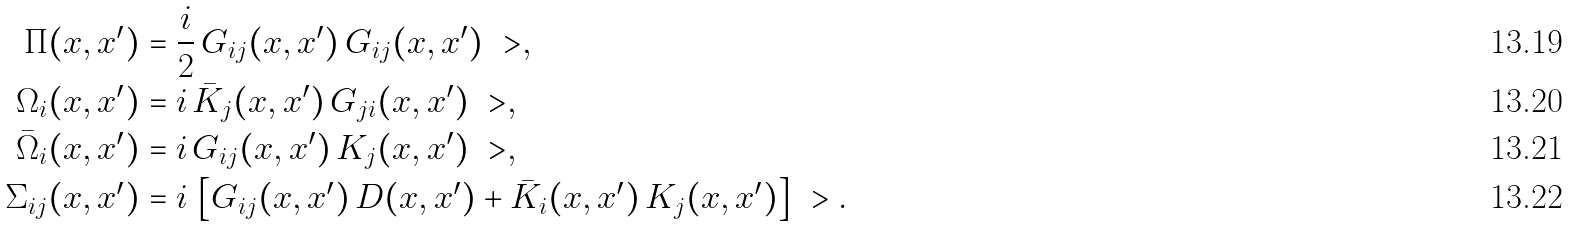<formula> <loc_0><loc_0><loc_500><loc_500>\Pi ( x , x ^ { \prime } ) & = \frac { i } { 2 } \, G _ { i j } ( x , x ^ { \prime } ) \, G _ { i j } ( x , x ^ { \prime } ) \ > , \\ \Omega _ { i } ( x , x ^ { \prime } ) & = i \, \bar { K } _ { j } ( x , x ^ { \prime } ) \, G _ { j i } ( x , x ^ { \prime } ) \ > , \\ \bar { \Omega } _ { i } ( x , x ^ { \prime } ) & = i \, G _ { i j } ( x , x ^ { \prime } ) \, K _ { j } ( x , x ^ { \prime } ) \ > , \\ \Sigma _ { i j } ( x , x ^ { \prime } ) & = i \, \left [ G _ { i j } ( x , x ^ { \prime } ) \, D ( x , x ^ { \prime } ) + \bar { K } _ { i } ( x , x ^ { \prime } ) \, K _ { j } ( x , x ^ { \prime } ) \right ] \ > .</formula> 